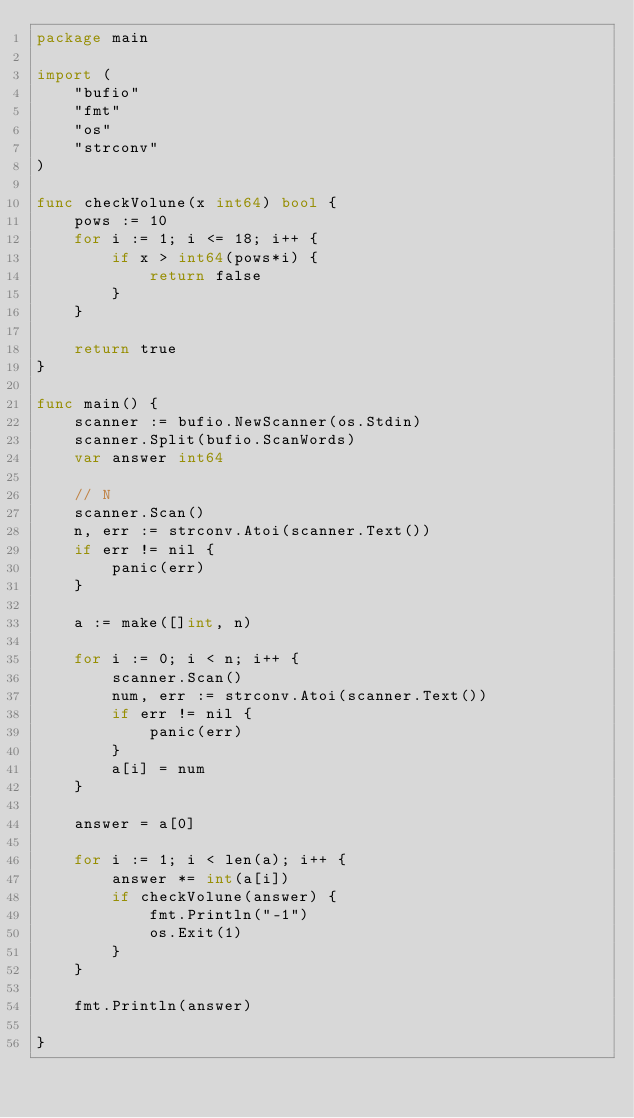<code> <loc_0><loc_0><loc_500><loc_500><_Go_>package main

import (
	"bufio"
	"fmt"
	"os"
	"strconv"
)

func checkVolune(x int64) bool {
	pows := 10
	for i := 1; i <= 18; i++ {
		if x > int64(pows*i) {
			return false
		}
	}

	return true
}

func main() {
	scanner := bufio.NewScanner(os.Stdin)
	scanner.Split(bufio.ScanWords)
	var answer int64

	// N
	scanner.Scan()
	n, err := strconv.Atoi(scanner.Text())
	if err != nil {
		panic(err)
	}

	a := make([]int, n)

	for i := 0; i < n; i++ {
		scanner.Scan()
		num, err := strconv.Atoi(scanner.Text())
		if err != nil {
			panic(err)
		}
		a[i] = num
	}

	answer = a[0]

	for i := 1; i < len(a); i++ {
		answer *= int(a[i])
		if checkVolune(answer) {
			fmt.Println("-1")
			os.Exit(1)
		}
	}

	fmt.Println(answer)

}
</code> 